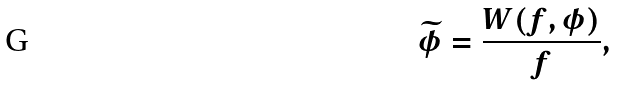Convert formula to latex. <formula><loc_0><loc_0><loc_500><loc_500>\widetilde { \phi } = \frac { W ( f , \phi ) } { f } ,</formula> 